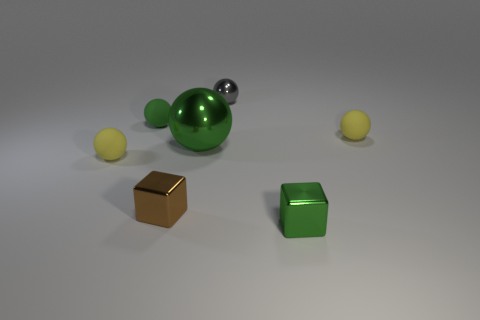Are there an equal number of rubber spheres right of the green rubber object and tiny brown shiny objects that are to the right of the brown object?
Ensure brevity in your answer.  No. What number of spheres are either small cyan metal objects or large green metal objects?
Your response must be concise. 1. How many other objects are made of the same material as the small gray object?
Provide a short and direct response. 3. There is a tiny rubber object that is the same color as the large object; what is its shape?
Your answer should be compact. Sphere. There is a small sphere that is both in front of the gray ball and on the right side of the brown object; what material is it made of?
Make the answer very short. Rubber. There is a tiny green thing that is left of the gray object; what is its shape?
Keep it short and to the point. Sphere. There is a green thing in front of the tiny object that is left of the tiny green ball; what is its shape?
Give a very brief answer. Cube. Are there any small brown things that have the same shape as the tiny green metallic object?
Your answer should be compact. Yes. The gray thing that is the same size as the green matte object is what shape?
Give a very brief answer. Sphere. There is a small yellow rubber sphere right of the tiny green thing that is left of the big metallic ball; is there a green sphere that is in front of it?
Give a very brief answer. Yes. 